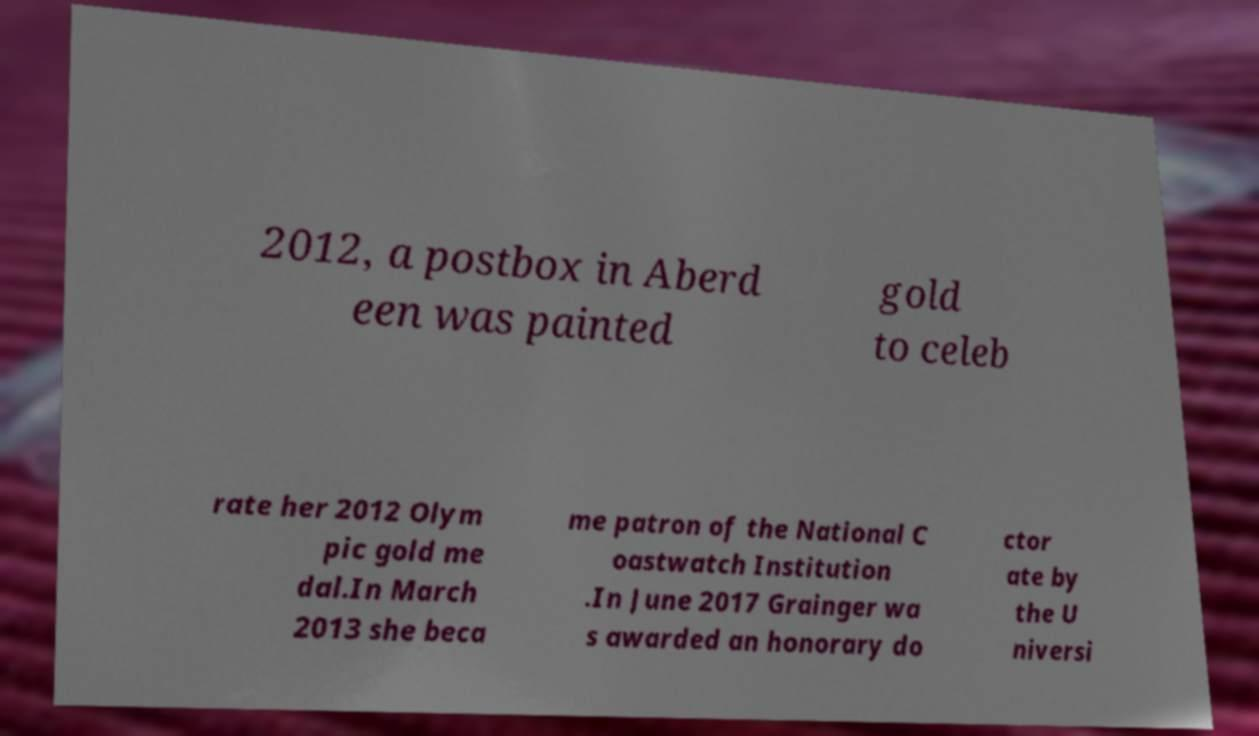For documentation purposes, I need the text within this image transcribed. Could you provide that? 2012, a postbox in Aberd een was painted gold to celeb rate her 2012 Olym pic gold me dal.In March 2013 she beca me patron of the National C oastwatch Institution .In June 2017 Grainger wa s awarded an honorary do ctor ate by the U niversi 